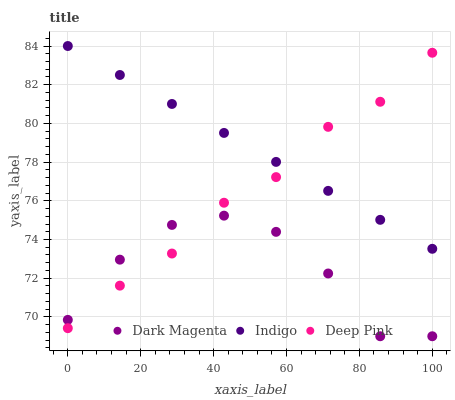Does Dark Magenta have the minimum area under the curve?
Answer yes or no. Yes. Does Indigo have the maximum area under the curve?
Answer yes or no. Yes. Does Indigo have the minimum area under the curve?
Answer yes or no. No. Does Dark Magenta have the maximum area under the curve?
Answer yes or no. No. Is Indigo the smoothest?
Answer yes or no. Yes. Is Dark Magenta the roughest?
Answer yes or no. Yes. Is Dark Magenta the smoothest?
Answer yes or no. No. Is Indigo the roughest?
Answer yes or no. No. Does Dark Magenta have the lowest value?
Answer yes or no. Yes. Does Indigo have the lowest value?
Answer yes or no. No. Does Indigo have the highest value?
Answer yes or no. Yes. Does Dark Magenta have the highest value?
Answer yes or no. No. Is Dark Magenta less than Indigo?
Answer yes or no. Yes. Is Indigo greater than Dark Magenta?
Answer yes or no. Yes. Does Deep Pink intersect Indigo?
Answer yes or no. Yes. Is Deep Pink less than Indigo?
Answer yes or no. No. Is Deep Pink greater than Indigo?
Answer yes or no. No. Does Dark Magenta intersect Indigo?
Answer yes or no. No. 